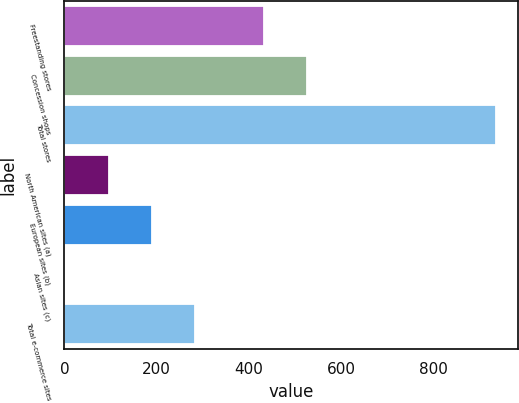Convert chart to OTSL. <chart><loc_0><loc_0><loc_500><loc_500><bar_chart><fcel>Freestanding stores<fcel>Concession shops<fcel>Total stores<fcel>North American sites (a)<fcel>European sites (b)<fcel>Asian sites (c)<fcel>Total e-commerce sites<nl><fcel>433<fcel>526.4<fcel>936<fcel>95.4<fcel>188.8<fcel>2<fcel>282.2<nl></chart> 